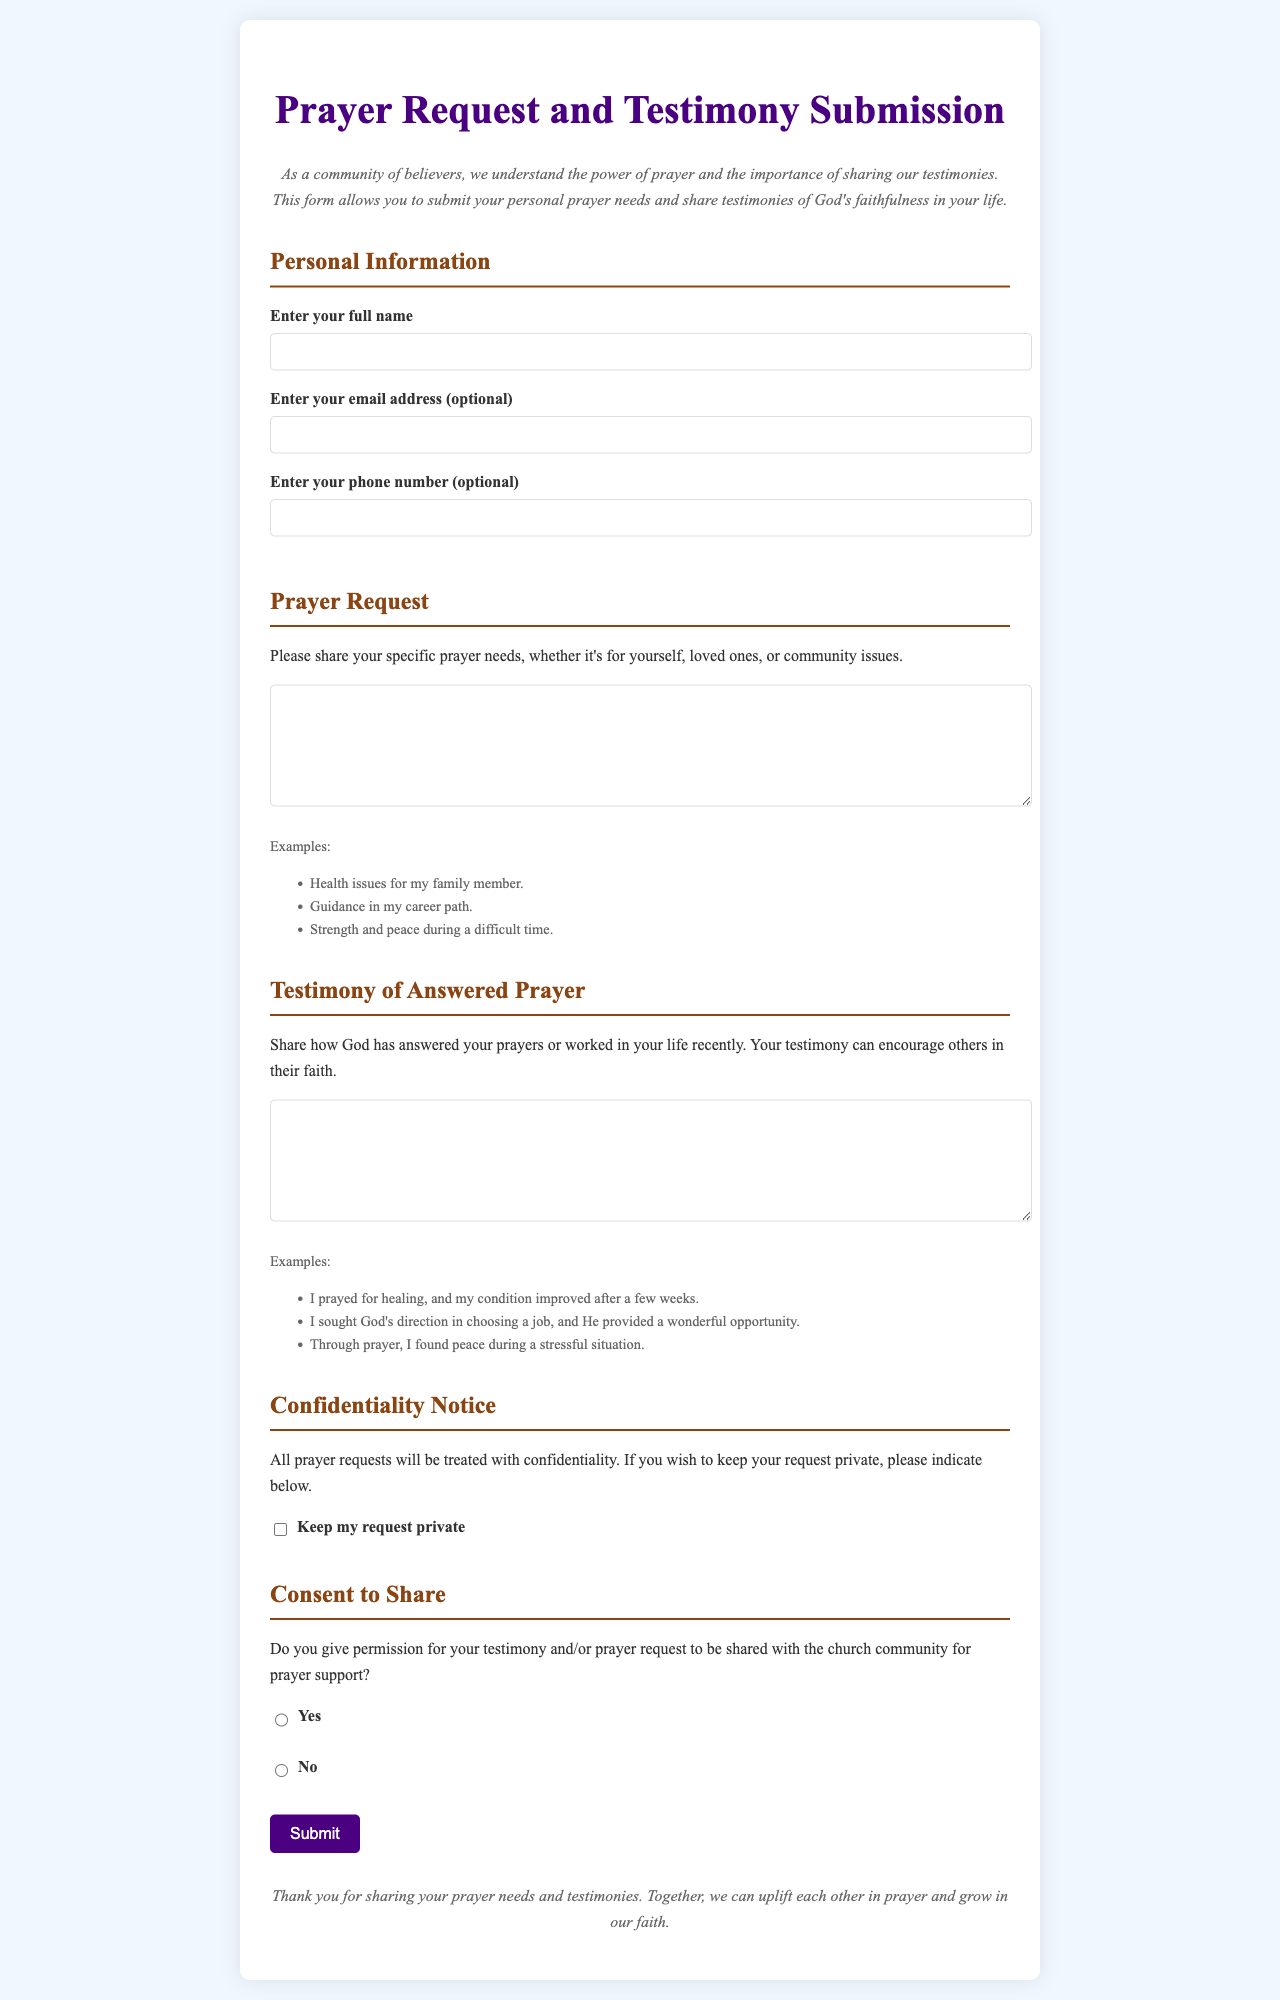what is the title of the document? The title of the document is prominently displayed at the top of the page.
Answer: Prayer Request and Testimony Submission what is the purpose of the form? The purpose is to submit personal prayer needs and share testimonies of God's faithfulness.
Answer: To submit personal prayer needs and share testimonies what are the examples provided for prayer requests? The document lists specific examples under the prayer request section to guide users.
Answer: Health issues for my family member, Guidance in my career path, Strength and peace during a difficult time how many sections are there in the form? The document is organized into distinct sections for clarity.
Answer: 5 sections is entering an email address mandatory? The document specifies whether certain information is required or optional.
Answer: No what color is the section title "Testimony of Answered Prayer"? The color of the section title reflects the design choices made in the document.
Answer: Brown what does the checkbox for "Keep my request private" allow users to do? The checkbox allows users to indicate their preference regarding the confidentiality of their request.
Answer: Indicate privacy preference what action does the "Submit" button perform? The button's function is clearly indicated through its label.
Answer: Submits the form what is required for consent if a user wants to share their testimony? The document outlines the requirement for users to indicate their choice regarding sharing.
Answer: Yes or No 